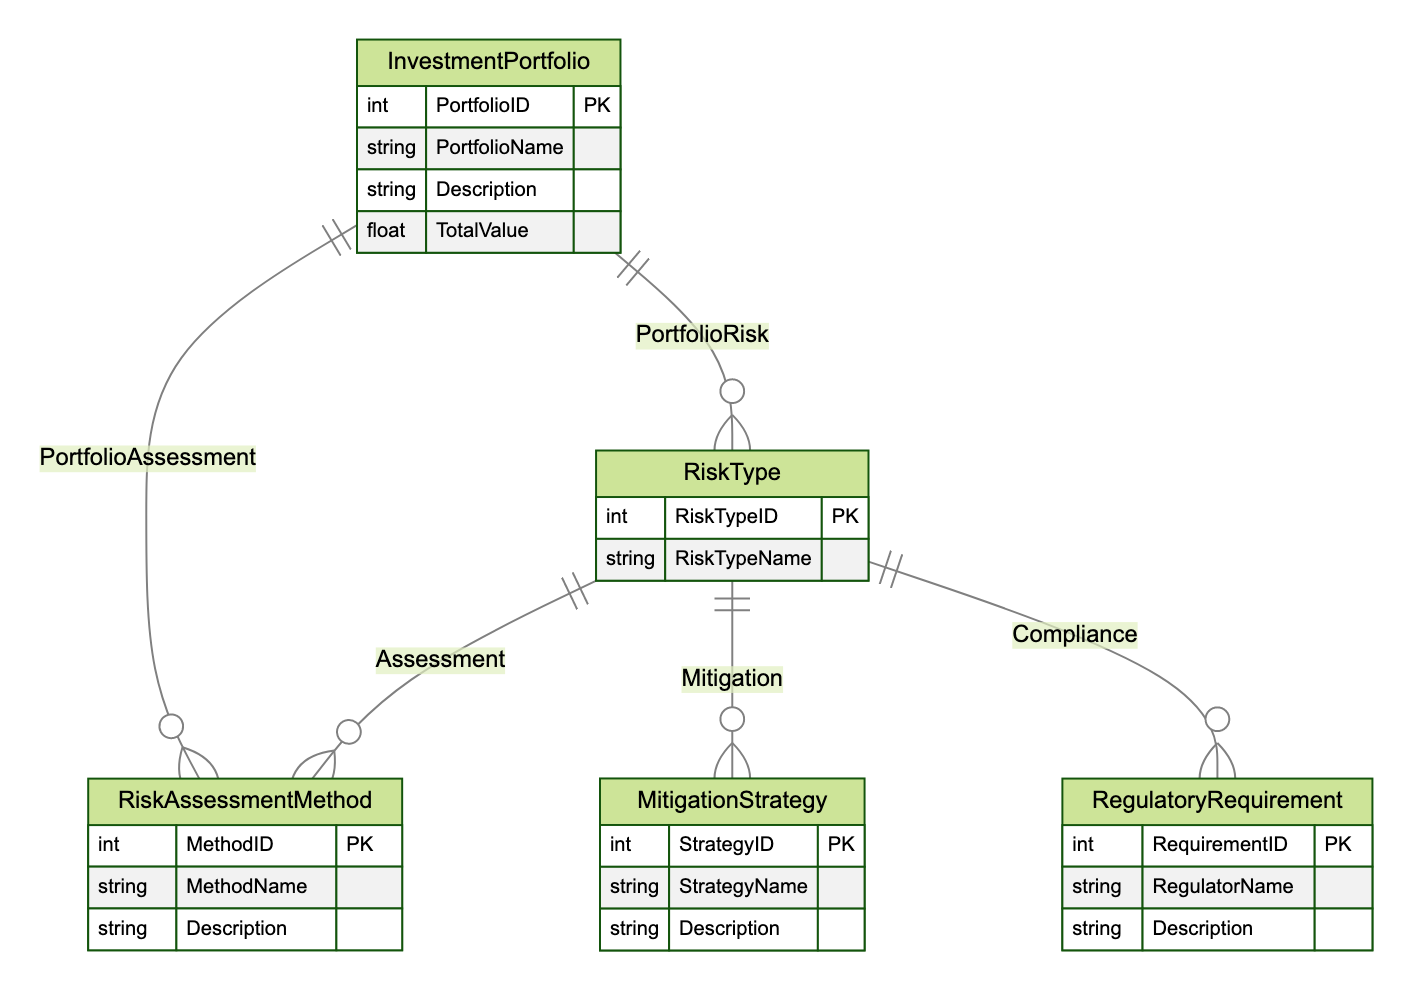What are the main entities depicted in this ERD? The diagram includes five entities: InvestmentPortfolio, RiskType, RiskAssessmentMethod, MitigationStrategy, and RegulatoryRequirement. This can be established by identifying the distinct components indicated in the diagram.
Answer: InvestmentPortfolio, RiskType, RiskAssessmentMethod, MitigationStrategy, RegulatoryRequirement How many relationships are defined in this ERD? There are five relationships indicated in the diagram connecting the entities. This is determined by counting the lines that represent connections between different entities.
Answer: Five What relationship connects InvestmentPortfolio and RiskAssessmentMethod? The relationship connecting InvestmentPortfolio and RiskAssessmentMethod is named PortfolioAssessment, establishing a many-to-many connection. This is evident from the specific relationship label that identifies the type of connection between these two entities.
Answer: PortfolioAssessment Which RiskType has a relationship with the MitigationStrategy? All risk types (like credit, market, operational) can relate to one or multiple MitigationStrategies through the Mitigation relationship established in the diagram. It is inferred from the many-to-many relationship indicated between RiskType and MitigationStrategy.
Answer: Any risk type How is the RiskAssessmentMethod characterized in the diagram? RiskAssessmentMethod is characterized by its attributes, including MethodID, MethodName, and Description. This information is directly taken from the entity definition portion of the ERD regarding RiskAssessmentMethod.
Answer: MethodID, MethodName, Description What is the purpose of the Compliance relationship in this ERD? The Compliance relationship connects RiskType and RegulatoryRequirement, indicating a need to adhere to regulatory standards for risk types. This can be understood from the relationship description and interconnection highlighted in the diagram.
Answer: Adhere to regulatory standards Which entity is associated with the TotalValue attribute? The TotalValue attribute is associated with the InvestmentPortfolio entity, specifying the financial worth of the respective portfolio. This fact is gleaned from the attributes listed under the InvestmentPortfolio entity.
Answer: InvestmentPortfolio How many attributes are defined for the RiskType entity? The RiskType entity has two defined attributes: RiskTypeID and RiskTypeName. This can be deduced by reviewing the attributes section of the RiskType entity in the diagram.
Answer: Two 